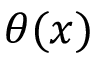Convert formula to latex. <formula><loc_0><loc_0><loc_500><loc_500>\theta ( x )</formula> 